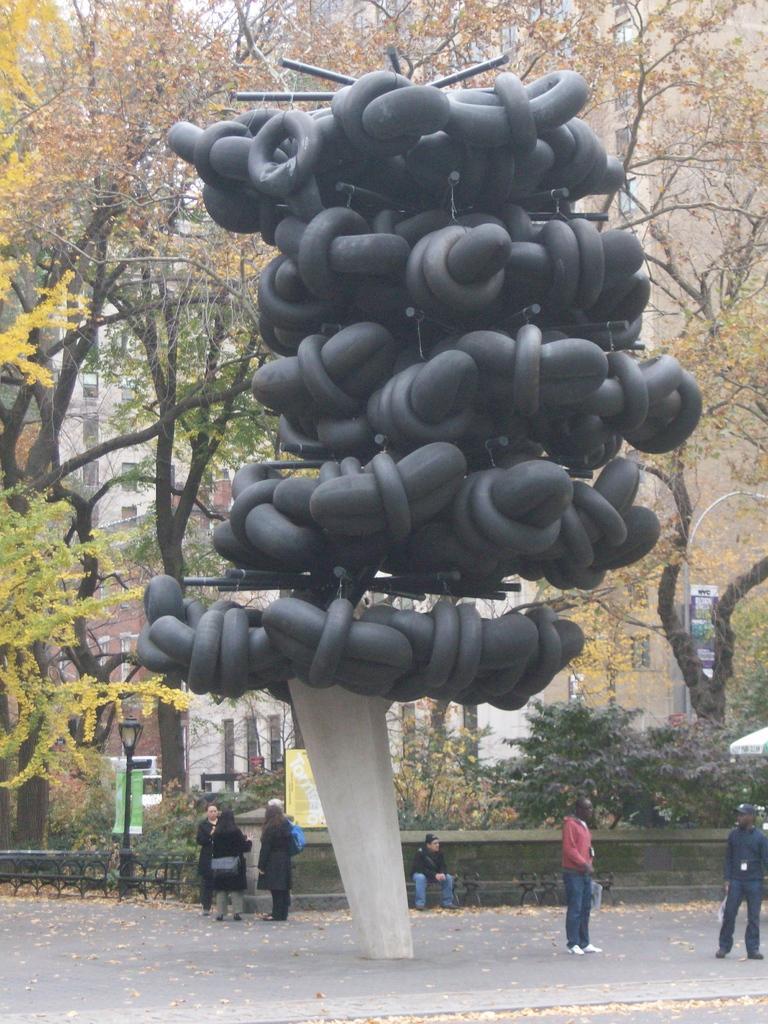How would you summarize this image in a sentence or two? In this picture I can see an architecture, there are group of people, there are poles, lights, there are benches, and in the background there are trees and there is a building with windows. 